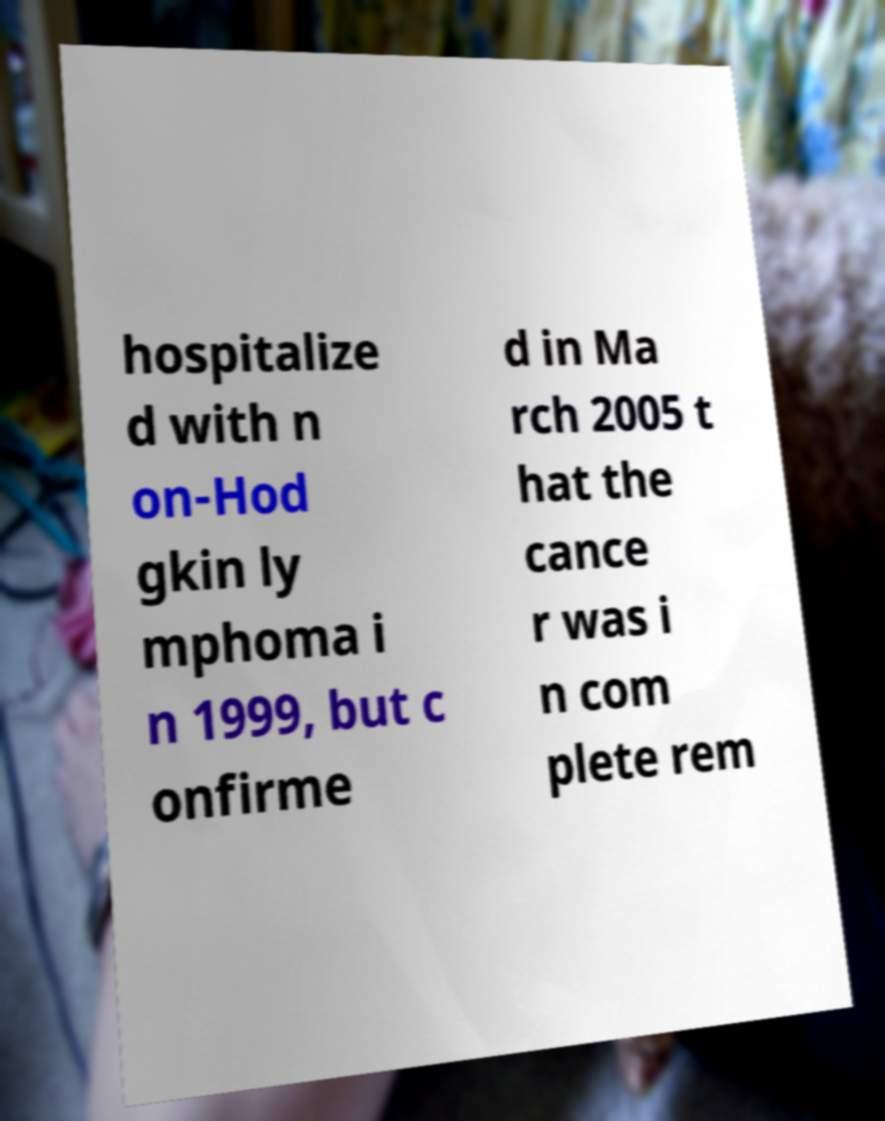Please read and relay the text visible in this image. What does it say? hospitalize d with n on-Hod gkin ly mphoma i n 1999, but c onfirme d in Ma rch 2005 t hat the cance r was i n com plete rem 